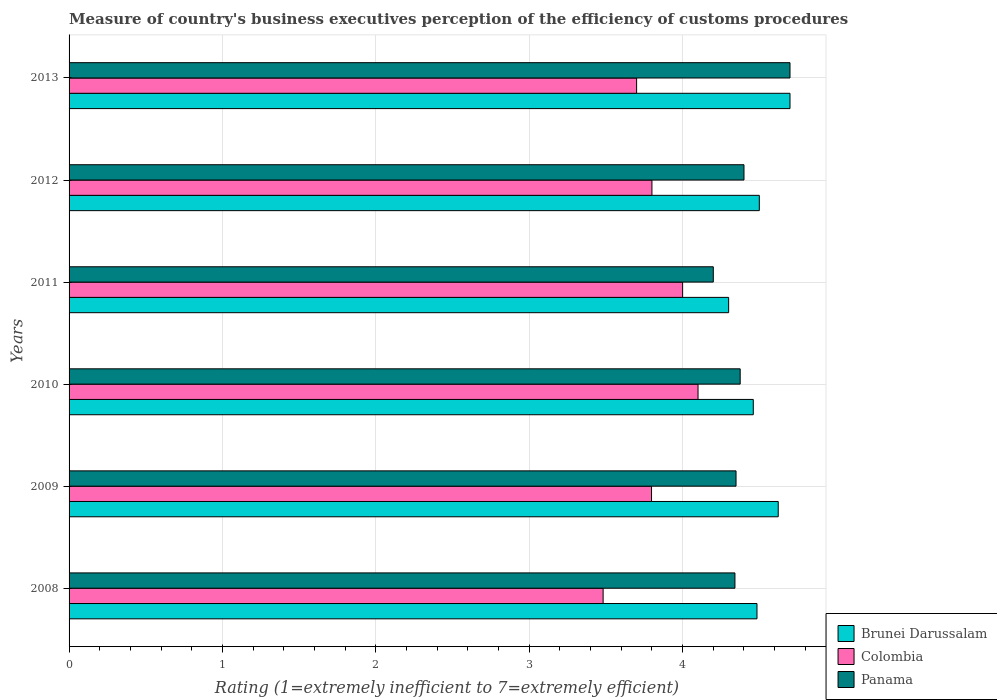How many different coloured bars are there?
Offer a very short reply. 3. How many groups of bars are there?
Offer a terse response. 6. Are the number of bars per tick equal to the number of legend labels?
Your answer should be very brief. Yes. Are the number of bars on each tick of the Y-axis equal?
Provide a short and direct response. Yes. What is the label of the 6th group of bars from the top?
Ensure brevity in your answer.  2008. In how many cases, is the number of bars for a given year not equal to the number of legend labels?
Keep it short and to the point. 0. What is the rating of the efficiency of customs procedure in Brunei Darussalam in 2009?
Provide a succinct answer. 4.62. Across all years, what is the maximum rating of the efficiency of customs procedure in Colombia?
Offer a terse response. 4.1. Across all years, what is the minimum rating of the efficiency of customs procedure in Colombia?
Give a very brief answer. 3.48. In which year was the rating of the efficiency of customs procedure in Brunei Darussalam minimum?
Keep it short and to the point. 2011. What is the total rating of the efficiency of customs procedure in Colombia in the graph?
Provide a short and direct response. 22.88. What is the difference between the rating of the efficiency of customs procedure in Panama in 2011 and that in 2012?
Your answer should be very brief. -0.2. What is the difference between the rating of the efficiency of customs procedure in Panama in 2010 and the rating of the efficiency of customs procedure in Brunei Darussalam in 2012?
Provide a succinct answer. -0.12. What is the average rating of the efficiency of customs procedure in Panama per year?
Make the answer very short. 4.39. In the year 2013, what is the difference between the rating of the efficiency of customs procedure in Colombia and rating of the efficiency of customs procedure in Panama?
Provide a short and direct response. -1. In how many years, is the rating of the efficiency of customs procedure in Colombia greater than 0.4 ?
Provide a succinct answer. 6. What is the ratio of the rating of the efficiency of customs procedure in Colombia in 2010 to that in 2013?
Give a very brief answer. 1.11. What is the difference between the highest and the second highest rating of the efficiency of customs procedure in Panama?
Provide a short and direct response. 0.3. What is the difference between the highest and the lowest rating of the efficiency of customs procedure in Brunei Darussalam?
Your answer should be very brief. 0.4. In how many years, is the rating of the efficiency of customs procedure in Brunei Darussalam greater than the average rating of the efficiency of customs procedure in Brunei Darussalam taken over all years?
Make the answer very short. 2. Is the sum of the rating of the efficiency of customs procedure in Brunei Darussalam in 2011 and 2013 greater than the maximum rating of the efficiency of customs procedure in Panama across all years?
Your response must be concise. Yes. What does the 1st bar from the top in 2013 represents?
Make the answer very short. Panama. What does the 3rd bar from the bottom in 2009 represents?
Provide a succinct answer. Panama. Is it the case that in every year, the sum of the rating of the efficiency of customs procedure in Brunei Darussalam and rating of the efficiency of customs procedure in Colombia is greater than the rating of the efficiency of customs procedure in Panama?
Your answer should be very brief. Yes. Are the values on the major ticks of X-axis written in scientific E-notation?
Your answer should be very brief. No. How many legend labels are there?
Provide a succinct answer. 3. What is the title of the graph?
Offer a very short reply. Measure of country's business executives perception of the efficiency of customs procedures. Does "Cuba" appear as one of the legend labels in the graph?
Provide a short and direct response. No. What is the label or title of the X-axis?
Keep it short and to the point. Rating (1=extremely inefficient to 7=extremely efficient). What is the Rating (1=extremely inefficient to 7=extremely efficient) of Brunei Darussalam in 2008?
Offer a very short reply. 4.48. What is the Rating (1=extremely inefficient to 7=extremely efficient) of Colombia in 2008?
Make the answer very short. 3.48. What is the Rating (1=extremely inefficient to 7=extremely efficient) of Panama in 2008?
Make the answer very short. 4.34. What is the Rating (1=extremely inefficient to 7=extremely efficient) in Brunei Darussalam in 2009?
Ensure brevity in your answer.  4.62. What is the Rating (1=extremely inefficient to 7=extremely efficient) of Colombia in 2009?
Provide a short and direct response. 3.8. What is the Rating (1=extremely inefficient to 7=extremely efficient) in Panama in 2009?
Provide a short and direct response. 4.35. What is the Rating (1=extremely inefficient to 7=extremely efficient) of Brunei Darussalam in 2010?
Ensure brevity in your answer.  4.46. What is the Rating (1=extremely inefficient to 7=extremely efficient) in Colombia in 2010?
Make the answer very short. 4.1. What is the Rating (1=extremely inefficient to 7=extremely efficient) in Panama in 2010?
Your answer should be very brief. 4.38. What is the Rating (1=extremely inefficient to 7=extremely efficient) of Colombia in 2011?
Make the answer very short. 4. What is the Rating (1=extremely inefficient to 7=extremely efficient) in Brunei Darussalam in 2012?
Your answer should be very brief. 4.5. What is the Rating (1=extremely inefficient to 7=extremely efficient) in Colombia in 2012?
Provide a succinct answer. 3.8. What is the Rating (1=extremely inefficient to 7=extremely efficient) of Brunei Darussalam in 2013?
Give a very brief answer. 4.7. What is the Rating (1=extremely inefficient to 7=extremely efficient) in Colombia in 2013?
Offer a very short reply. 3.7. Across all years, what is the maximum Rating (1=extremely inefficient to 7=extremely efficient) of Colombia?
Keep it short and to the point. 4.1. Across all years, what is the maximum Rating (1=extremely inefficient to 7=extremely efficient) of Panama?
Your response must be concise. 4.7. Across all years, what is the minimum Rating (1=extremely inefficient to 7=extremely efficient) in Brunei Darussalam?
Provide a succinct answer. 4.3. Across all years, what is the minimum Rating (1=extremely inefficient to 7=extremely efficient) of Colombia?
Make the answer very short. 3.48. Across all years, what is the minimum Rating (1=extremely inefficient to 7=extremely efficient) of Panama?
Provide a short and direct response. 4.2. What is the total Rating (1=extremely inefficient to 7=extremely efficient) in Brunei Darussalam in the graph?
Your response must be concise. 27.07. What is the total Rating (1=extremely inefficient to 7=extremely efficient) of Colombia in the graph?
Ensure brevity in your answer.  22.88. What is the total Rating (1=extremely inefficient to 7=extremely efficient) in Panama in the graph?
Provide a short and direct response. 26.36. What is the difference between the Rating (1=extremely inefficient to 7=extremely efficient) in Brunei Darussalam in 2008 and that in 2009?
Offer a terse response. -0.14. What is the difference between the Rating (1=extremely inefficient to 7=extremely efficient) of Colombia in 2008 and that in 2009?
Provide a short and direct response. -0.32. What is the difference between the Rating (1=extremely inefficient to 7=extremely efficient) of Panama in 2008 and that in 2009?
Offer a terse response. -0.01. What is the difference between the Rating (1=extremely inefficient to 7=extremely efficient) of Brunei Darussalam in 2008 and that in 2010?
Your response must be concise. 0.02. What is the difference between the Rating (1=extremely inefficient to 7=extremely efficient) of Colombia in 2008 and that in 2010?
Your answer should be compact. -0.62. What is the difference between the Rating (1=extremely inefficient to 7=extremely efficient) in Panama in 2008 and that in 2010?
Give a very brief answer. -0.03. What is the difference between the Rating (1=extremely inefficient to 7=extremely efficient) of Brunei Darussalam in 2008 and that in 2011?
Your answer should be compact. 0.18. What is the difference between the Rating (1=extremely inefficient to 7=extremely efficient) in Colombia in 2008 and that in 2011?
Provide a succinct answer. -0.52. What is the difference between the Rating (1=extremely inefficient to 7=extremely efficient) in Panama in 2008 and that in 2011?
Provide a succinct answer. 0.14. What is the difference between the Rating (1=extremely inefficient to 7=extremely efficient) in Brunei Darussalam in 2008 and that in 2012?
Ensure brevity in your answer.  -0.02. What is the difference between the Rating (1=extremely inefficient to 7=extremely efficient) of Colombia in 2008 and that in 2012?
Provide a short and direct response. -0.32. What is the difference between the Rating (1=extremely inefficient to 7=extremely efficient) of Panama in 2008 and that in 2012?
Your response must be concise. -0.06. What is the difference between the Rating (1=extremely inefficient to 7=extremely efficient) of Brunei Darussalam in 2008 and that in 2013?
Your answer should be very brief. -0.22. What is the difference between the Rating (1=extremely inefficient to 7=extremely efficient) in Colombia in 2008 and that in 2013?
Offer a very short reply. -0.22. What is the difference between the Rating (1=extremely inefficient to 7=extremely efficient) of Panama in 2008 and that in 2013?
Offer a very short reply. -0.36. What is the difference between the Rating (1=extremely inefficient to 7=extremely efficient) in Brunei Darussalam in 2009 and that in 2010?
Keep it short and to the point. 0.16. What is the difference between the Rating (1=extremely inefficient to 7=extremely efficient) of Colombia in 2009 and that in 2010?
Give a very brief answer. -0.3. What is the difference between the Rating (1=extremely inefficient to 7=extremely efficient) in Panama in 2009 and that in 2010?
Make the answer very short. -0.03. What is the difference between the Rating (1=extremely inefficient to 7=extremely efficient) of Brunei Darussalam in 2009 and that in 2011?
Provide a succinct answer. 0.32. What is the difference between the Rating (1=extremely inefficient to 7=extremely efficient) of Colombia in 2009 and that in 2011?
Offer a terse response. -0.2. What is the difference between the Rating (1=extremely inefficient to 7=extremely efficient) of Panama in 2009 and that in 2011?
Keep it short and to the point. 0.15. What is the difference between the Rating (1=extremely inefficient to 7=extremely efficient) of Brunei Darussalam in 2009 and that in 2012?
Offer a very short reply. 0.12. What is the difference between the Rating (1=extremely inefficient to 7=extremely efficient) of Colombia in 2009 and that in 2012?
Make the answer very short. -0. What is the difference between the Rating (1=extremely inefficient to 7=extremely efficient) of Panama in 2009 and that in 2012?
Your answer should be compact. -0.05. What is the difference between the Rating (1=extremely inefficient to 7=extremely efficient) in Brunei Darussalam in 2009 and that in 2013?
Offer a very short reply. -0.08. What is the difference between the Rating (1=extremely inefficient to 7=extremely efficient) of Colombia in 2009 and that in 2013?
Keep it short and to the point. 0.1. What is the difference between the Rating (1=extremely inefficient to 7=extremely efficient) in Panama in 2009 and that in 2013?
Give a very brief answer. -0.35. What is the difference between the Rating (1=extremely inefficient to 7=extremely efficient) in Brunei Darussalam in 2010 and that in 2011?
Provide a succinct answer. 0.16. What is the difference between the Rating (1=extremely inefficient to 7=extremely efficient) in Colombia in 2010 and that in 2011?
Your answer should be very brief. 0.1. What is the difference between the Rating (1=extremely inefficient to 7=extremely efficient) of Panama in 2010 and that in 2011?
Provide a short and direct response. 0.18. What is the difference between the Rating (1=extremely inefficient to 7=extremely efficient) of Brunei Darussalam in 2010 and that in 2012?
Your response must be concise. -0.04. What is the difference between the Rating (1=extremely inefficient to 7=extremely efficient) of Colombia in 2010 and that in 2012?
Provide a succinct answer. 0.3. What is the difference between the Rating (1=extremely inefficient to 7=extremely efficient) in Panama in 2010 and that in 2012?
Provide a short and direct response. -0.02. What is the difference between the Rating (1=extremely inefficient to 7=extremely efficient) in Brunei Darussalam in 2010 and that in 2013?
Your answer should be compact. -0.24. What is the difference between the Rating (1=extremely inefficient to 7=extremely efficient) of Colombia in 2010 and that in 2013?
Ensure brevity in your answer.  0.4. What is the difference between the Rating (1=extremely inefficient to 7=extremely efficient) of Panama in 2010 and that in 2013?
Offer a very short reply. -0.32. What is the difference between the Rating (1=extremely inefficient to 7=extremely efficient) of Brunei Darussalam in 2011 and that in 2012?
Offer a terse response. -0.2. What is the difference between the Rating (1=extremely inefficient to 7=extremely efficient) of Panama in 2011 and that in 2013?
Offer a very short reply. -0.5. What is the difference between the Rating (1=extremely inefficient to 7=extremely efficient) of Panama in 2012 and that in 2013?
Ensure brevity in your answer.  -0.3. What is the difference between the Rating (1=extremely inefficient to 7=extremely efficient) of Brunei Darussalam in 2008 and the Rating (1=extremely inefficient to 7=extremely efficient) of Colombia in 2009?
Your response must be concise. 0.69. What is the difference between the Rating (1=extremely inefficient to 7=extremely efficient) of Brunei Darussalam in 2008 and the Rating (1=extremely inefficient to 7=extremely efficient) of Panama in 2009?
Offer a very short reply. 0.14. What is the difference between the Rating (1=extremely inefficient to 7=extremely efficient) of Colombia in 2008 and the Rating (1=extremely inefficient to 7=extremely efficient) of Panama in 2009?
Your response must be concise. -0.87. What is the difference between the Rating (1=extremely inefficient to 7=extremely efficient) of Brunei Darussalam in 2008 and the Rating (1=extremely inefficient to 7=extremely efficient) of Colombia in 2010?
Offer a very short reply. 0.38. What is the difference between the Rating (1=extremely inefficient to 7=extremely efficient) of Brunei Darussalam in 2008 and the Rating (1=extremely inefficient to 7=extremely efficient) of Panama in 2010?
Provide a succinct answer. 0.11. What is the difference between the Rating (1=extremely inefficient to 7=extremely efficient) in Colombia in 2008 and the Rating (1=extremely inefficient to 7=extremely efficient) in Panama in 2010?
Give a very brief answer. -0.89. What is the difference between the Rating (1=extremely inefficient to 7=extremely efficient) in Brunei Darussalam in 2008 and the Rating (1=extremely inefficient to 7=extremely efficient) in Colombia in 2011?
Offer a very short reply. 0.48. What is the difference between the Rating (1=extremely inefficient to 7=extremely efficient) in Brunei Darussalam in 2008 and the Rating (1=extremely inefficient to 7=extremely efficient) in Panama in 2011?
Provide a short and direct response. 0.28. What is the difference between the Rating (1=extremely inefficient to 7=extremely efficient) in Colombia in 2008 and the Rating (1=extremely inefficient to 7=extremely efficient) in Panama in 2011?
Give a very brief answer. -0.72. What is the difference between the Rating (1=extremely inefficient to 7=extremely efficient) in Brunei Darussalam in 2008 and the Rating (1=extremely inefficient to 7=extremely efficient) in Colombia in 2012?
Give a very brief answer. 0.68. What is the difference between the Rating (1=extremely inefficient to 7=extremely efficient) in Brunei Darussalam in 2008 and the Rating (1=extremely inefficient to 7=extremely efficient) in Panama in 2012?
Offer a terse response. 0.08. What is the difference between the Rating (1=extremely inefficient to 7=extremely efficient) of Colombia in 2008 and the Rating (1=extremely inefficient to 7=extremely efficient) of Panama in 2012?
Keep it short and to the point. -0.92. What is the difference between the Rating (1=extremely inefficient to 7=extremely efficient) of Brunei Darussalam in 2008 and the Rating (1=extremely inefficient to 7=extremely efficient) of Colombia in 2013?
Your answer should be compact. 0.78. What is the difference between the Rating (1=extremely inefficient to 7=extremely efficient) of Brunei Darussalam in 2008 and the Rating (1=extremely inefficient to 7=extremely efficient) of Panama in 2013?
Offer a very short reply. -0.22. What is the difference between the Rating (1=extremely inefficient to 7=extremely efficient) in Colombia in 2008 and the Rating (1=extremely inefficient to 7=extremely efficient) in Panama in 2013?
Provide a short and direct response. -1.22. What is the difference between the Rating (1=extremely inefficient to 7=extremely efficient) in Brunei Darussalam in 2009 and the Rating (1=extremely inefficient to 7=extremely efficient) in Colombia in 2010?
Your answer should be compact. 0.52. What is the difference between the Rating (1=extremely inefficient to 7=extremely efficient) of Brunei Darussalam in 2009 and the Rating (1=extremely inefficient to 7=extremely efficient) of Panama in 2010?
Keep it short and to the point. 0.25. What is the difference between the Rating (1=extremely inefficient to 7=extremely efficient) of Colombia in 2009 and the Rating (1=extremely inefficient to 7=extremely efficient) of Panama in 2010?
Ensure brevity in your answer.  -0.58. What is the difference between the Rating (1=extremely inefficient to 7=extremely efficient) of Brunei Darussalam in 2009 and the Rating (1=extremely inefficient to 7=extremely efficient) of Colombia in 2011?
Provide a short and direct response. 0.62. What is the difference between the Rating (1=extremely inefficient to 7=extremely efficient) of Brunei Darussalam in 2009 and the Rating (1=extremely inefficient to 7=extremely efficient) of Panama in 2011?
Ensure brevity in your answer.  0.42. What is the difference between the Rating (1=extremely inefficient to 7=extremely efficient) of Colombia in 2009 and the Rating (1=extremely inefficient to 7=extremely efficient) of Panama in 2011?
Offer a terse response. -0.4. What is the difference between the Rating (1=extremely inefficient to 7=extremely efficient) of Brunei Darussalam in 2009 and the Rating (1=extremely inefficient to 7=extremely efficient) of Colombia in 2012?
Offer a terse response. 0.82. What is the difference between the Rating (1=extremely inefficient to 7=extremely efficient) of Brunei Darussalam in 2009 and the Rating (1=extremely inefficient to 7=extremely efficient) of Panama in 2012?
Provide a succinct answer. 0.22. What is the difference between the Rating (1=extremely inefficient to 7=extremely efficient) of Colombia in 2009 and the Rating (1=extremely inefficient to 7=extremely efficient) of Panama in 2012?
Offer a terse response. -0.6. What is the difference between the Rating (1=extremely inefficient to 7=extremely efficient) in Brunei Darussalam in 2009 and the Rating (1=extremely inefficient to 7=extremely efficient) in Colombia in 2013?
Keep it short and to the point. 0.92. What is the difference between the Rating (1=extremely inefficient to 7=extremely efficient) in Brunei Darussalam in 2009 and the Rating (1=extremely inefficient to 7=extremely efficient) in Panama in 2013?
Provide a succinct answer. -0.08. What is the difference between the Rating (1=extremely inefficient to 7=extremely efficient) of Colombia in 2009 and the Rating (1=extremely inefficient to 7=extremely efficient) of Panama in 2013?
Give a very brief answer. -0.9. What is the difference between the Rating (1=extremely inefficient to 7=extremely efficient) of Brunei Darussalam in 2010 and the Rating (1=extremely inefficient to 7=extremely efficient) of Colombia in 2011?
Your response must be concise. 0.46. What is the difference between the Rating (1=extremely inefficient to 7=extremely efficient) of Brunei Darussalam in 2010 and the Rating (1=extremely inefficient to 7=extremely efficient) of Panama in 2011?
Provide a succinct answer. 0.26. What is the difference between the Rating (1=extremely inefficient to 7=extremely efficient) of Colombia in 2010 and the Rating (1=extremely inefficient to 7=extremely efficient) of Panama in 2011?
Your response must be concise. -0.1. What is the difference between the Rating (1=extremely inefficient to 7=extremely efficient) in Brunei Darussalam in 2010 and the Rating (1=extremely inefficient to 7=extremely efficient) in Colombia in 2012?
Your answer should be very brief. 0.66. What is the difference between the Rating (1=extremely inefficient to 7=extremely efficient) of Brunei Darussalam in 2010 and the Rating (1=extremely inefficient to 7=extremely efficient) of Panama in 2012?
Your response must be concise. 0.06. What is the difference between the Rating (1=extremely inefficient to 7=extremely efficient) of Colombia in 2010 and the Rating (1=extremely inefficient to 7=extremely efficient) of Panama in 2012?
Ensure brevity in your answer.  -0.3. What is the difference between the Rating (1=extremely inefficient to 7=extremely efficient) in Brunei Darussalam in 2010 and the Rating (1=extremely inefficient to 7=extremely efficient) in Colombia in 2013?
Your answer should be compact. 0.76. What is the difference between the Rating (1=extremely inefficient to 7=extremely efficient) in Brunei Darussalam in 2010 and the Rating (1=extremely inefficient to 7=extremely efficient) in Panama in 2013?
Provide a short and direct response. -0.24. What is the difference between the Rating (1=extremely inefficient to 7=extremely efficient) in Colombia in 2010 and the Rating (1=extremely inefficient to 7=extremely efficient) in Panama in 2013?
Your response must be concise. -0.6. What is the difference between the Rating (1=extremely inefficient to 7=extremely efficient) in Brunei Darussalam in 2011 and the Rating (1=extremely inefficient to 7=extremely efficient) in Panama in 2012?
Your answer should be very brief. -0.1. What is the difference between the Rating (1=extremely inefficient to 7=extremely efficient) of Colombia in 2011 and the Rating (1=extremely inefficient to 7=extremely efficient) of Panama in 2012?
Provide a succinct answer. -0.4. What is the difference between the Rating (1=extremely inefficient to 7=extremely efficient) of Brunei Darussalam in 2012 and the Rating (1=extremely inefficient to 7=extremely efficient) of Panama in 2013?
Offer a very short reply. -0.2. What is the average Rating (1=extremely inefficient to 7=extremely efficient) of Brunei Darussalam per year?
Ensure brevity in your answer.  4.51. What is the average Rating (1=extremely inefficient to 7=extremely efficient) of Colombia per year?
Your answer should be compact. 3.81. What is the average Rating (1=extremely inefficient to 7=extremely efficient) of Panama per year?
Your answer should be compact. 4.39. In the year 2008, what is the difference between the Rating (1=extremely inefficient to 7=extremely efficient) in Brunei Darussalam and Rating (1=extremely inefficient to 7=extremely efficient) in Colombia?
Provide a succinct answer. 1. In the year 2008, what is the difference between the Rating (1=extremely inefficient to 7=extremely efficient) in Brunei Darussalam and Rating (1=extremely inefficient to 7=extremely efficient) in Panama?
Provide a succinct answer. 0.14. In the year 2008, what is the difference between the Rating (1=extremely inefficient to 7=extremely efficient) of Colombia and Rating (1=extremely inefficient to 7=extremely efficient) of Panama?
Keep it short and to the point. -0.86. In the year 2009, what is the difference between the Rating (1=extremely inefficient to 7=extremely efficient) in Brunei Darussalam and Rating (1=extremely inefficient to 7=extremely efficient) in Colombia?
Keep it short and to the point. 0.83. In the year 2009, what is the difference between the Rating (1=extremely inefficient to 7=extremely efficient) of Brunei Darussalam and Rating (1=extremely inefficient to 7=extremely efficient) of Panama?
Offer a terse response. 0.28. In the year 2009, what is the difference between the Rating (1=extremely inefficient to 7=extremely efficient) of Colombia and Rating (1=extremely inefficient to 7=extremely efficient) of Panama?
Make the answer very short. -0.55. In the year 2010, what is the difference between the Rating (1=extremely inefficient to 7=extremely efficient) of Brunei Darussalam and Rating (1=extremely inefficient to 7=extremely efficient) of Colombia?
Give a very brief answer. 0.36. In the year 2010, what is the difference between the Rating (1=extremely inefficient to 7=extremely efficient) of Brunei Darussalam and Rating (1=extremely inefficient to 7=extremely efficient) of Panama?
Your response must be concise. 0.09. In the year 2010, what is the difference between the Rating (1=extremely inefficient to 7=extremely efficient) of Colombia and Rating (1=extremely inefficient to 7=extremely efficient) of Panama?
Your response must be concise. -0.27. In the year 2011, what is the difference between the Rating (1=extremely inefficient to 7=extremely efficient) in Brunei Darussalam and Rating (1=extremely inefficient to 7=extremely efficient) in Colombia?
Ensure brevity in your answer.  0.3. In the year 2012, what is the difference between the Rating (1=extremely inefficient to 7=extremely efficient) in Brunei Darussalam and Rating (1=extremely inefficient to 7=extremely efficient) in Colombia?
Provide a short and direct response. 0.7. In the year 2013, what is the difference between the Rating (1=extremely inefficient to 7=extremely efficient) of Colombia and Rating (1=extremely inefficient to 7=extremely efficient) of Panama?
Ensure brevity in your answer.  -1. What is the ratio of the Rating (1=extremely inefficient to 7=extremely efficient) of Colombia in 2008 to that in 2009?
Your response must be concise. 0.92. What is the ratio of the Rating (1=extremely inefficient to 7=extremely efficient) of Panama in 2008 to that in 2009?
Offer a terse response. 1. What is the ratio of the Rating (1=extremely inefficient to 7=extremely efficient) of Brunei Darussalam in 2008 to that in 2010?
Give a very brief answer. 1.01. What is the ratio of the Rating (1=extremely inefficient to 7=extremely efficient) of Colombia in 2008 to that in 2010?
Offer a terse response. 0.85. What is the ratio of the Rating (1=extremely inefficient to 7=extremely efficient) of Panama in 2008 to that in 2010?
Offer a very short reply. 0.99. What is the ratio of the Rating (1=extremely inefficient to 7=extremely efficient) of Brunei Darussalam in 2008 to that in 2011?
Your answer should be very brief. 1.04. What is the ratio of the Rating (1=extremely inefficient to 7=extremely efficient) in Colombia in 2008 to that in 2011?
Give a very brief answer. 0.87. What is the ratio of the Rating (1=extremely inefficient to 7=extremely efficient) in Panama in 2008 to that in 2011?
Offer a terse response. 1.03. What is the ratio of the Rating (1=extremely inefficient to 7=extremely efficient) in Colombia in 2008 to that in 2012?
Offer a terse response. 0.92. What is the ratio of the Rating (1=extremely inefficient to 7=extremely efficient) in Panama in 2008 to that in 2012?
Your answer should be compact. 0.99. What is the ratio of the Rating (1=extremely inefficient to 7=extremely efficient) of Brunei Darussalam in 2008 to that in 2013?
Make the answer very short. 0.95. What is the ratio of the Rating (1=extremely inefficient to 7=extremely efficient) in Colombia in 2008 to that in 2013?
Your response must be concise. 0.94. What is the ratio of the Rating (1=extremely inefficient to 7=extremely efficient) of Panama in 2008 to that in 2013?
Provide a short and direct response. 0.92. What is the ratio of the Rating (1=extremely inefficient to 7=extremely efficient) in Brunei Darussalam in 2009 to that in 2010?
Your response must be concise. 1.04. What is the ratio of the Rating (1=extremely inefficient to 7=extremely efficient) in Colombia in 2009 to that in 2010?
Provide a short and direct response. 0.93. What is the ratio of the Rating (1=extremely inefficient to 7=extremely efficient) of Brunei Darussalam in 2009 to that in 2011?
Ensure brevity in your answer.  1.08. What is the ratio of the Rating (1=extremely inefficient to 7=extremely efficient) of Colombia in 2009 to that in 2011?
Offer a terse response. 0.95. What is the ratio of the Rating (1=extremely inefficient to 7=extremely efficient) in Panama in 2009 to that in 2011?
Offer a terse response. 1.04. What is the ratio of the Rating (1=extremely inefficient to 7=extremely efficient) in Brunei Darussalam in 2009 to that in 2012?
Your response must be concise. 1.03. What is the ratio of the Rating (1=extremely inefficient to 7=extremely efficient) in Colombia in 2009 to that in 2012?
Your answer should be compact. 1. What is the ratio of the Rating (1=extremely inefficient to 7=extremely efficient) of Brunei Darussalam in 2009 to that in 2013?
Offer a terse response. 0.98. What is the ratio of the Rating (1=extremely inefficient to 7=extremely efficient) of Colombia in 2009 to that in 2013?
Offer a terse response. 1.03. What is the ratio of the Rating (1=extremely inefficient to 7=extremely efficient) in Panama in 2009 to that in 2013?
Ensure brevity in your answer.  0.93. What is the ratio of the Rating (1=extremely inefficient to 7=extremely efficient) of Brunei Darussalam in 2010 to that in 2011?
Provide a succinct answer. 1.04. What is the ratio of the Rating (1=extremely inefficient to 7=extremely efficient) of Colombia in 2010 to that in 2011?
Your response must be concise. 1.03. What is the ratio of the Rating (1=extremely inefficient to 7=extremely efficient) of Panama in 2010 to that in 2011?
Offer a very short reply. 1.04. What is the ratio of the Rating (1=extremely inefficient to 7=extremely efficient) of Colombia in 2010 to that in 2012?
Your answer should be compact. 1.08. What is the ratio of the Rating (1=extremely inefficient to 7=extremely efficient) of Brunei Darussalam in 2010 to that in 2013?
Keep it short and to the point. 0.95. What is the ratio of the Rating (1=extremely inefficient to 7=extremely efficient) in Colombia in 2010 to that in 2013?
Offer a very short reply. 1.11. What is the ratio of the Rating (1=extremely inefficient to 7=extremely efficient) in Panama in 2010 to that in 2013?
Make the answer very short. 0.93. What is the ratio of the Rating (1=extremely inefficient to 7=extremely efficient) in Brunei Darussalam in 2011 to that in 2012?
Give a very brief answer. 0.96. What is the ratio of the Rating (1=extremely inefficient to 7=extremely efficient) in Colombia in 2011 to that in 2012?
Keep it short and to the point. 1.05. What is the ratio of the Rating (1=extremely inefficient to 7=extremely efficient) in Panama in 2011 to that in 2012?
Offer a very short reply. 0.95. What is the ratio of the Rating (1=extremely inefficient to 7=extremely efficient) in Brunei Darussalam in 2011 to that in 2013?
Ensure brevity in your answer.  0.91. What is the ratio of the Rating (1=extremely inefficient to 7=extremely efficient) in Colombia in 2011 to that in 2013?
Ensure brevity in your answer.  1.08. What is the ratio of the Rating (1=extremely inefficient to 7=extremely efficient) of Panama in 2011 to that in 2013?
Ensure brevity in your answer.  0.89. What is the ratio of the Rating (1=extremely inefficient to 7=extremely efficient) of Brunei Darussalam in 2012 to that in 2013?
Keep it short and to the point. 0.96. What is the ratio of the Rating (1=extremely inefficient to 7=extremely efficient) of Panama in 2012 to that in 2013?
Provide a succinct answer. 0.94. What is the difference between the highest and the second highest Rating (1=extremely inefficient to 7=extremely efficient) in Brunei Darussalam?
Your answer should be compact. 0.08. What is the difference between the highest and the second highest Rating (1=extremely inefficient to 7=extremely efficient) of Colombia?
Keep it short and to the point. 0.1. What is the difference between the highest and the second highest Rating (1=extremely inefficient to 7=extremely efficient) in Panama?
Your answer should be compact. 0.3. What is the difference between the highest and the lowest Rating (1=extremely inefficient to 7=extremely efficient) of Colombia?
Provide a succinct answer. 0.62. What is the difference between the highest and the lowest Rating (1=extremely inefficient to 7=extremely efficient) of Panama?
Provide a succinct answer. 0.5. 